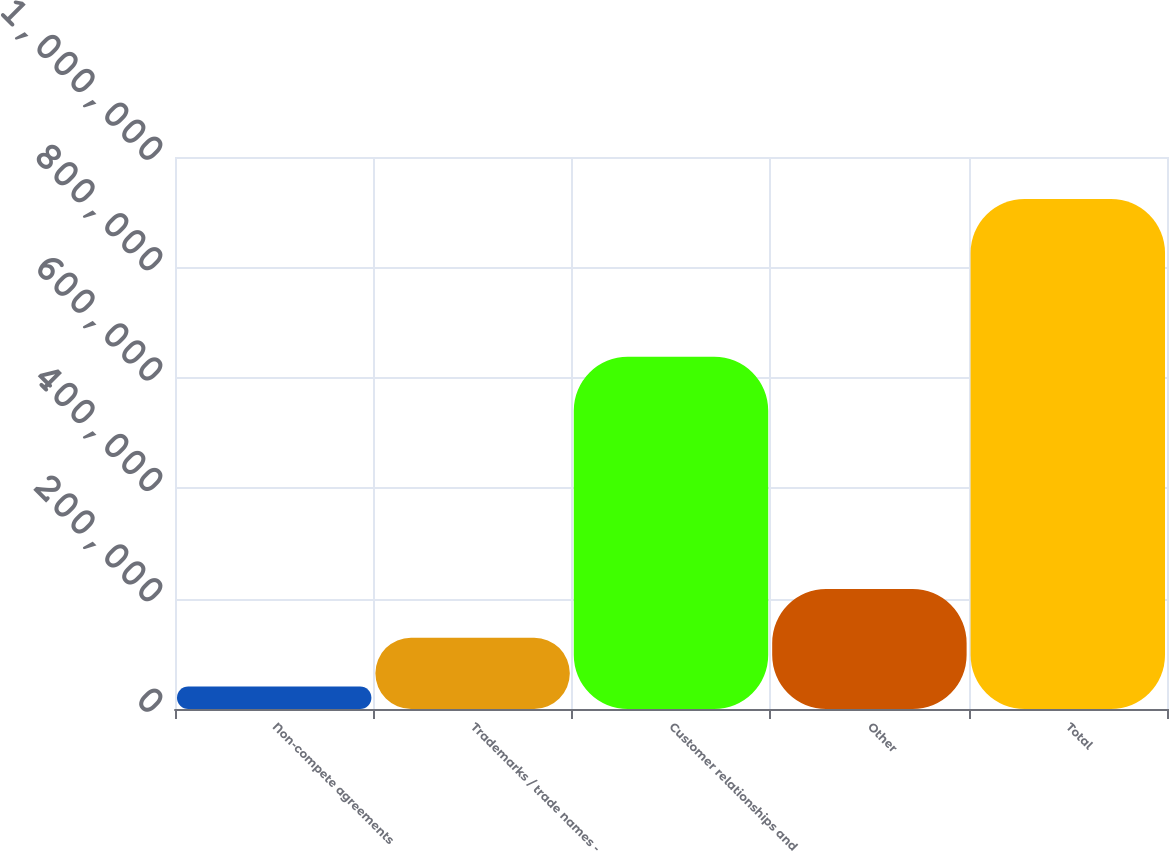Convert chart to OTSL. <chart><loc_0><loc_0><loc_500><loc_500><bar_chart><fcel>Non-compete agreements<fcel>Trademarks / trade names -<fcel>Customer relationships and<fcel>Other<fcel>Total<nl><fcel>40898<fcel>129202<fcel>638276<fcel>217506<fcel>923940<nl></chart> 